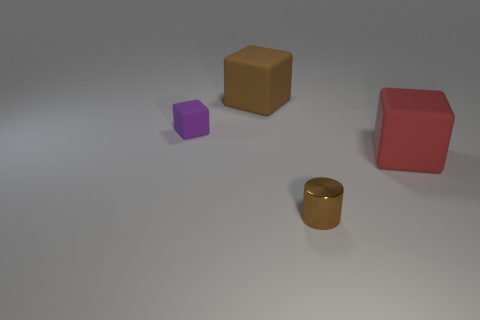There is a brown thing that is right of the big block behind the big cube right of the tiny brown metallic cylinder; what is its shape?
Keep it short and to the point. Cylinder. How many other objects are the same material as the large brown thing?
Offer a very short reply. 2. Does the big block that is behind the large red thing have the same material as the thing that is in front of the red thing?
Offer a very short reply. No. How many objects are both in front of the purple rubber object and behind the cylinder?
Your response must be concise. 1. Are there any other tiny purple things that have the same shape as the tiny rubber thing?
Offer a terse response. No. There is a brown shiny object that is the same size as the purple block; what shape is it?
Make the answer very short. Cylinder. Are there the same number of big brown things that are behind the big brown cube and big blocks that are behind the large red rubber block?
Your answer should be very brief. No. What size is the matte cube left of the big object left of the large red thing?
Your response must be concise. Small. Is there a yellow block of the same size as the cylinder?
Provide a succinct answer. No. The other tiny cube that is the same material as the brown block is what color?
Ensure brevity in your answer.  Purple. 